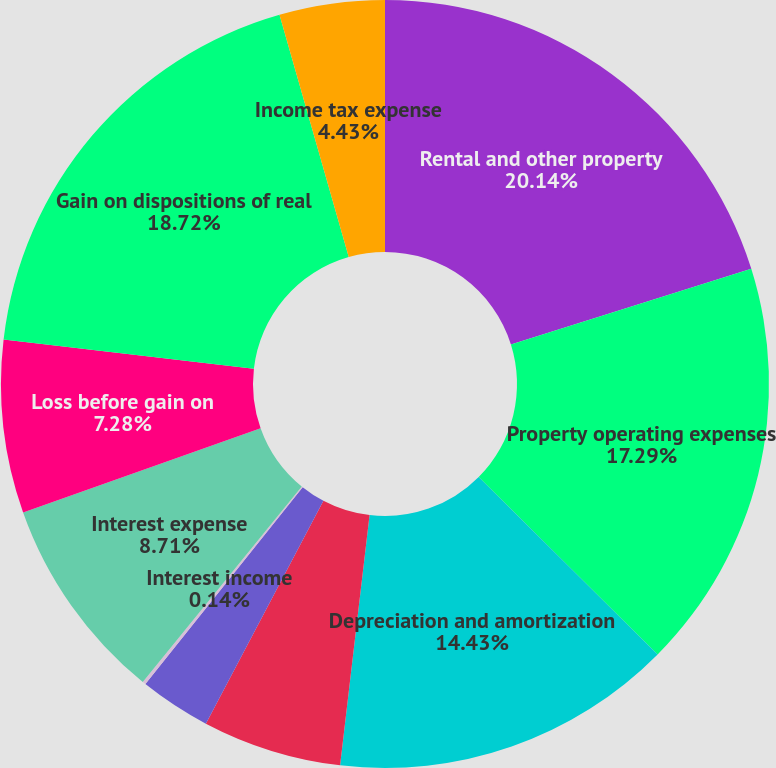<chart> <loc_0><loc_0><loc_500><loc_500><pie_chart><fcel>Rental and other property<fcel>Property operating expenses<fcel>Depreciation and amortization<fcel>Provision for real estate<fcel>Operating (loss) income<fcel>Interest income<fcel>Interest expense<fcel>Loss before gain on<fcel>Gain on dispositions of real<fcel>Income tax expense<nl><fcel>20.15%<fcel>17.29%<fcel>14.43%<fcel>5.86%<fcel>3.0%<fcel>0.14%<fcel>8.71%<fcel>7.28%<fcel>18.72%<fcel>4.43%<nl></chart> 